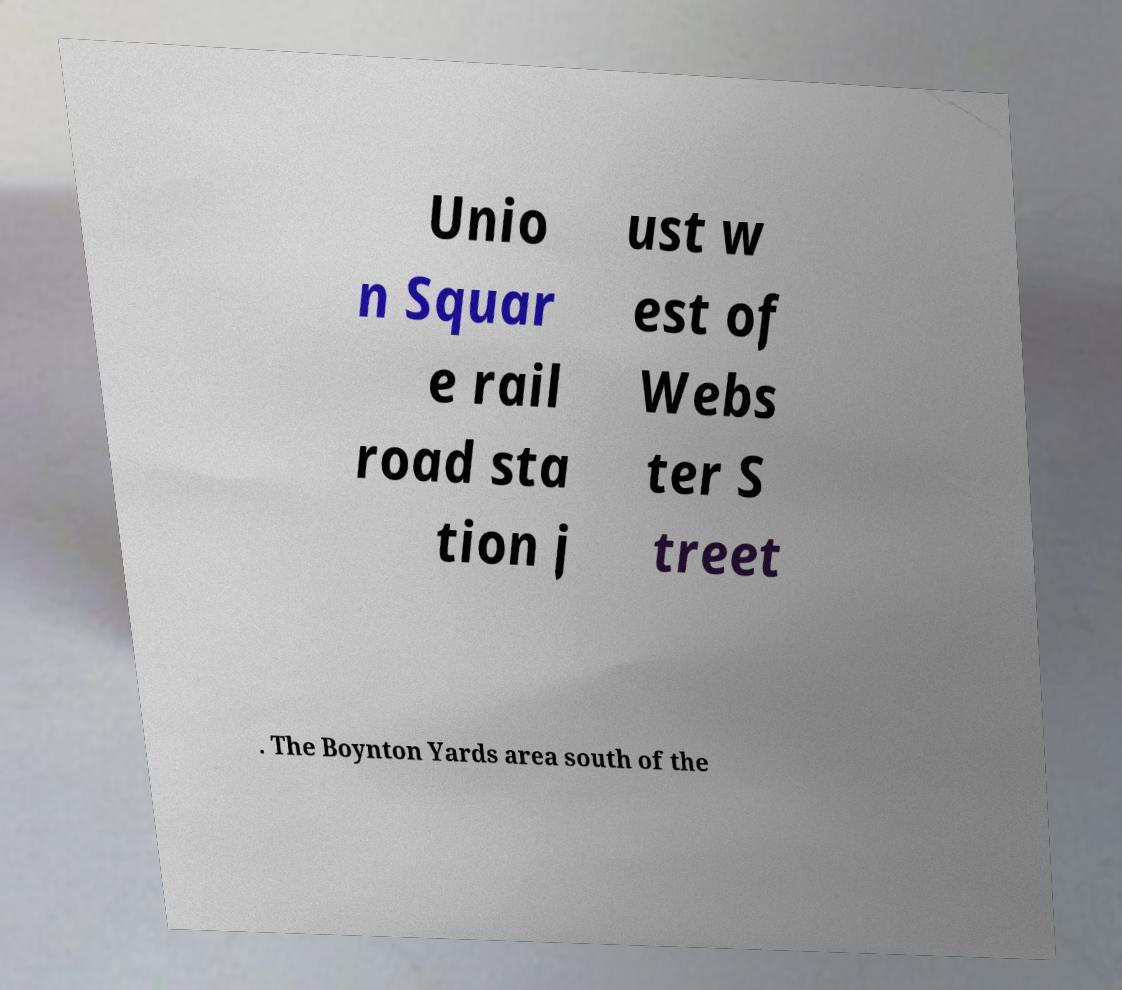I need the written content from this picture converted into text. Can you do that? Unio n Squar e rail road sta tion j ust w est of Webs ter S treet . The Boynton Yards area south of the 